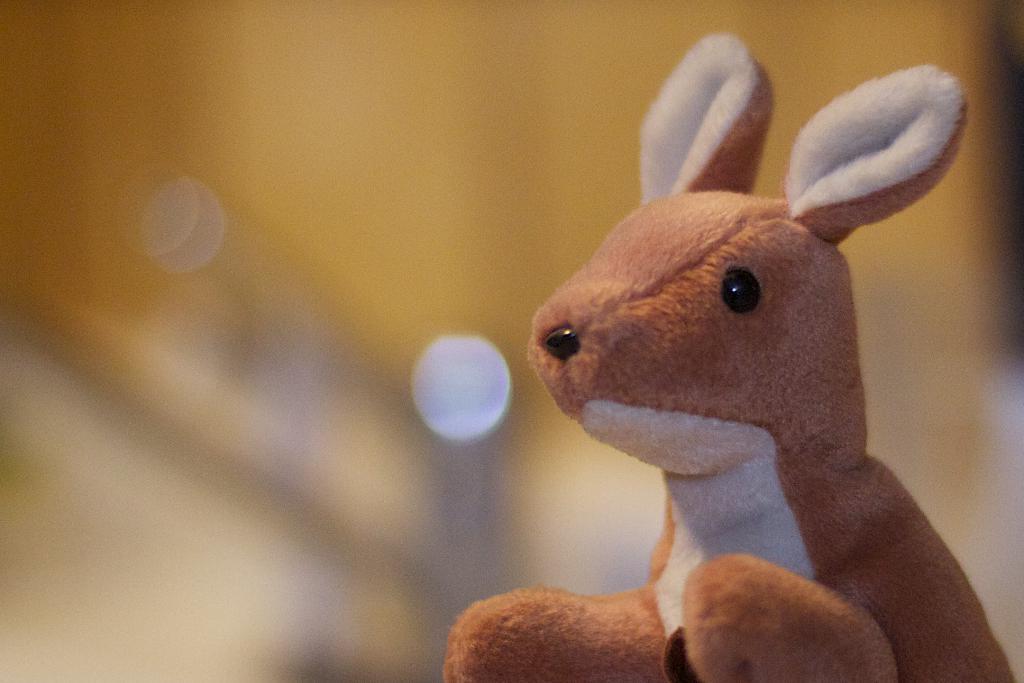Can you describe this image briefly? In this image we can see a soft toy. 